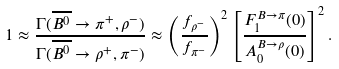<formula> <loc_0><loc_0><loc_500><loc_500>1 \approx \frac { \Gamma ( \overline { B ^ { 0 } } \rightarrow \pi ^ { + } , \rho ^ { - } ) } { \Gamma ( \overline { B ^ { 0 } } \rightarrow \rho ^ { + } , \pi ^ { - } ) } \approx \left ( \frac { f _ { \rho ^ { - } } } { f _ { \pi ^ { - } } } \right ) ^ { 2 } \left [ \frac { F _ { 1 } ^ { B \rightarrow \pi } ( 0 ) } { A _ { 0 } ^ { B \rightarrow \rho } ( 0 ) } \right ] ^ { 2 } .</formula> 